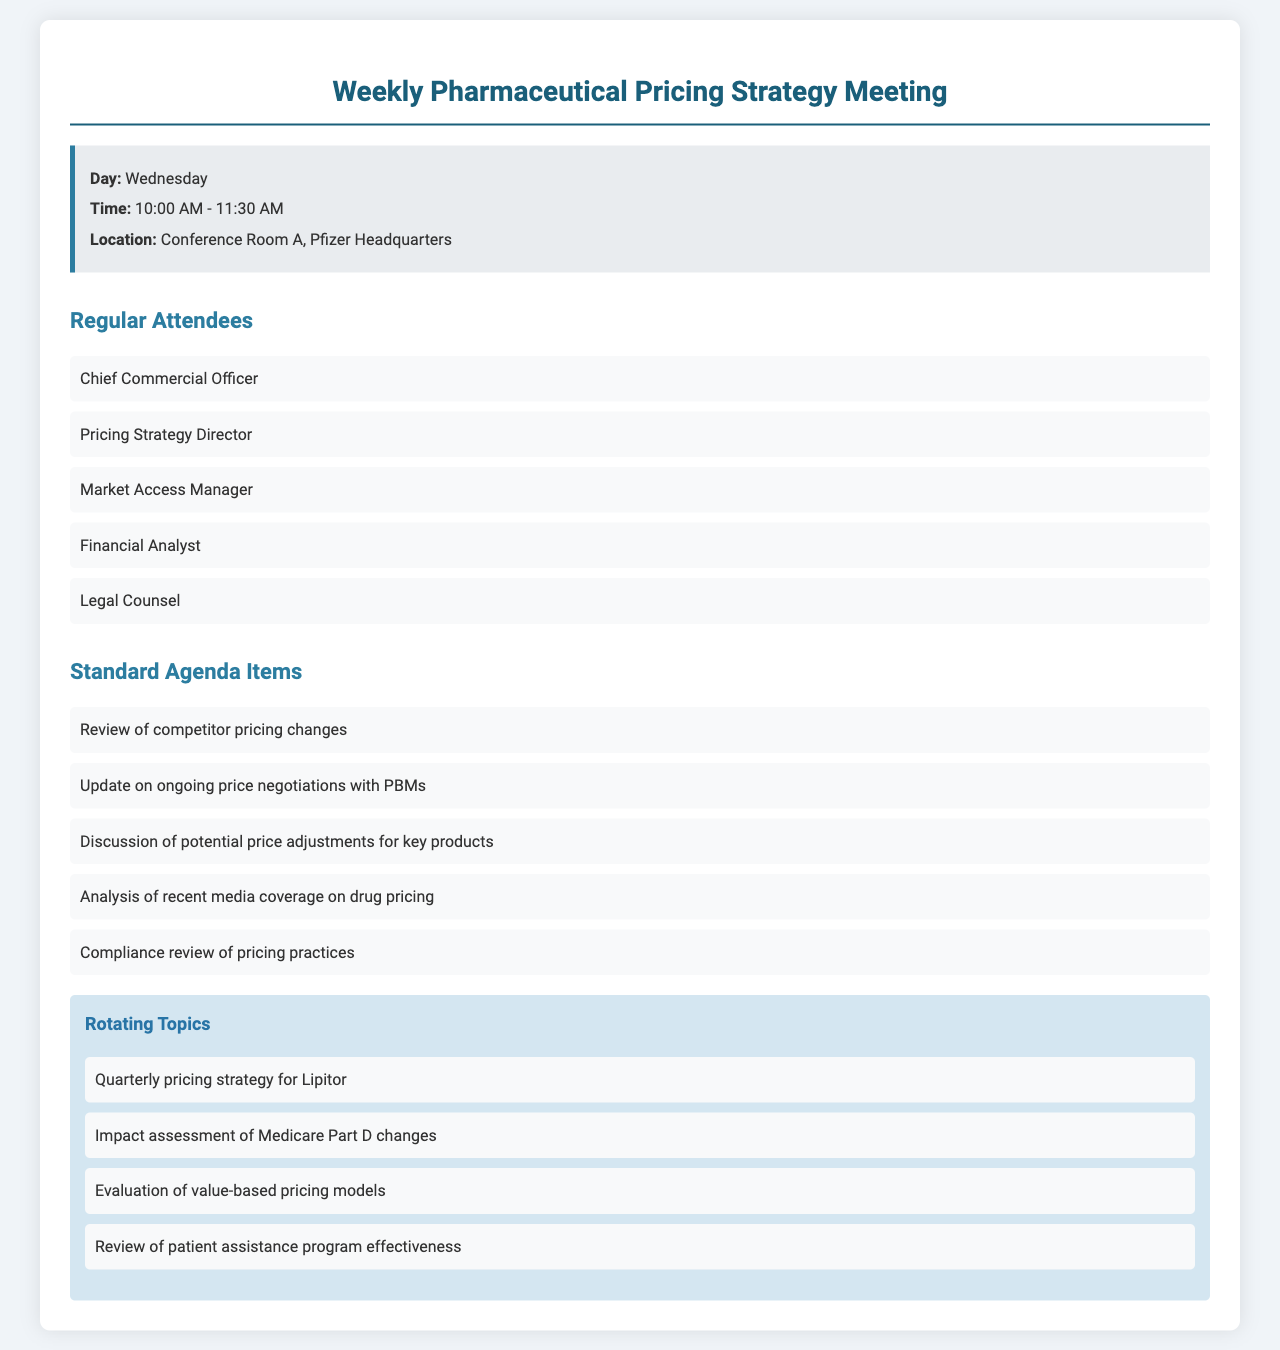what day of the week is the meeting held? The recurring day of the meeting is specified in the document, and it is Wednesday.
Answer: Wednesday what time does the meeting start? The meeting time is provided in the document, stating it starts at 10:00 AM.
Answer: 10:00 AM who is the Pricing Strategy Director? The document lists the regular attendees, where "Pricing Strategy Director" is mentioned as one of them.
Answer: Pricing Strategy Director how many standard agenda items are there? The document lists the standard agenda items and counts them to determine the total number. There are five items.
Answer: 5 what is one of the rotating topics? The document includes a section for rotating topics and specifies several of them; one can be picked from that list.
Answer: Quarterly pricing strategy for Lipitor how long is the meeting scheduled for? The time duration of the meeting is indicated by the start and end times provided in the document, totaling one and a half hours.
Answer: 1.5 hours who is responsible for legal advice during the meeting? The document lists the attendees, and "Legal Counsel" indicates who will provide legal advice.
Answer: Legal Counsel what is the location of the meeting? The document specifies where the meeting will take place, naming the venue.
Answer: Conference Room A, Pfizer Headquarters what does the meeting discuss regarding drug pricing? The document highlights specific agenda items that focus on discussions of drug pricing practices.
Answer: Compliance review of pricing practices how frequently does this meeting occur? The document indicates the recurrence of the meeting schedule, specifying it is weekly.
Answer: Weekly 